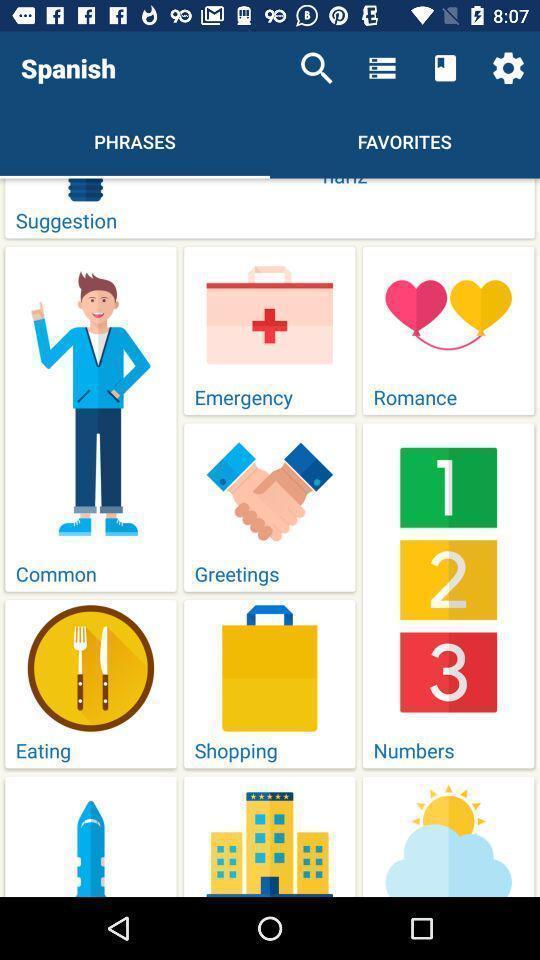What details can you identify in this image? Screen page displaying various categories in language learning application. 